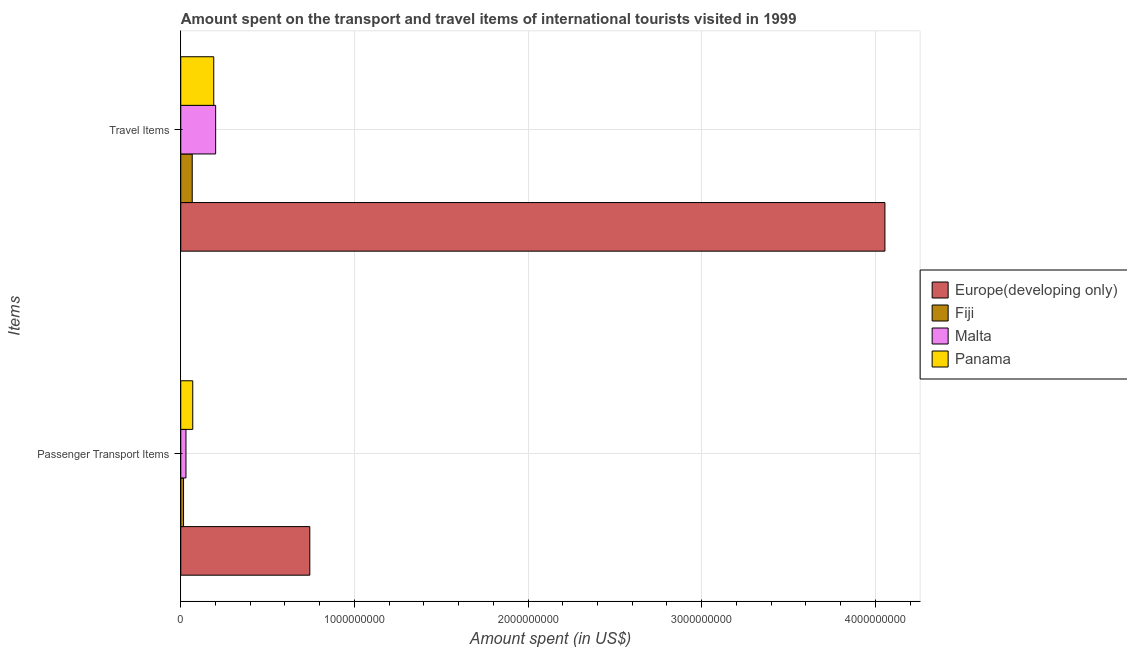How many groups of bars are there?
Your response must be concise. 2. Are the number of bars on each tick of the Y-axis equal?
Give a very brief answer. Yes. How many bars are there on the 2nd tick from the top?
Your response must be concise. 4. How many bars are there on the 2nd tick from the bottom?
Offer a very short reply. 4. What is the label of the 2nd group of bars from the top?
Ensure brevity in your answer.  Passenger Transport Items. What is the amount spent in travel items in Panama?
Your answer should be compact. 1.90e+08. Across all countries, what is the maximum amount spent on passenger transport items?
Offer a terse response. 7.43e+08. Across all countries, what is the minimum amount spent on passenger transport items?
Make the answer very short. 1.60e+07. In which country was the amount spent in travel items maximum?
Offer a very short reply. Europe(developing only). In which country was the amount spent in travel items minimum?
Give a very brief answer. Fiji. What is the total amount spent on passenger transport items in the graph?
Give a very brief answer. 8.58e+08. What is the difference between the amount spent in travel items in Fiji and that in Malta?
Keep it short and to the point. -1.35e+08. What is the difference between the amount spent in travel items in Malta and the amount spent on passenger transport items in Europe(developing only)?
Offer a terse response. -5.42e+08. What is the average amount spent on passenger transport items per country?
Give a very brief answer. 2.15e+08. What is the ratio of the amount spent in travel items in Malta to that in Fiji?
Give a very brief answer. 3.05. Is the amount spent in travel items in Europe(developing only) less than that in Fiji?
Give a very brief answer. No. In how many countries, is the amount spent on passenger transport items greater than the average amount spent on passenger transport items taken over all countries?
Make the answer very short. 1. What does the 4th bar from the top in Passenger Transport Items represents?
Provide a short and direct response. Europe(developing only). What does the 2nd bar from the bottom in Travel Items represents?
Your answer should be compact. Fiji. How many bars are there?
Ensure brevity in your answer.  8. How many countries are there in the graph?
Provide a short and direct response. 4. Are the values on the major ticks of X-axis written in scientific E-notation?
Your answer should be compact. No. Does the graph contain grids?
Your answer should be compact. Yes. Where does the legend appear in the graph?
Keep it short and to the point. Center right. What is the title of the graph?
Offer a very short reply. Amount spent on the transport and travel items of international tourists visited in 1999. Does "Yemen, Rep." appear as one of the legend labels in the graph?
Make the answer very short. No. What is the label or title of the X-axis?
Your answer should be compact. Amount spent (in US$). What is the label or title of the Y-axis?
Make the answer very short. Items. What is the Amount spent (in US$) in Europe(developing only) in Passenger Transport Items?
Keep it short and to the point. 7.43e+08. What is the Amount spent (in US$) in Fiji in Passenger Transport Items?
Your response must be concise. 1.60e+07. What is the Amount spent (in US$) in Malta in Passenger Transport Items?
Your answer should be compact. 3.00e+07. What is the Amount spent (in US$) of Panama in Passenger Transport Items?
Your response must be concise. 6.90e+07. What is the Amount spent (in US$) in Europe(developing only) in Travel Items?
Give a very brief answer. 4.06e+09. What is the Amount spent (in US$) in Fiji in Travel Items?
Offer a very short reply. 6.60e+07. What is the Amount spent (in US$) of Malta in Travel Items?
Ensure brevity in your answer.  2.01e+08. What is the Amount spent (in US$) in Panama in Travel Items?
Ensure brevity in your answer.  1.90e+08. Across all Items, what is the maximum Amount spent (in US$) of Europe(developing only)?
Give a very brief answer. 4.06e+09. Across all Items, what is the maximum Amount spent (in US$) in Fiji?
Make the answer very short. 6.60e+07. Across all Items, what is the maximum Amount spent (in US$) of Malta?
Provide a short and direct response. 2.01e+08. Across all Items, what is the maximum Amount spent (in US$) of Panama?
Your answer should be compact. 1.90e+08. Across all Items, what is the minimum Amount spent (in US$) in Europe(developing only)?
Give a very brief answer. 7.43e+08. Across all Items, what is the minimum Amount spent (in US$) in Fiji?
Offer a terse response. 1.60e+07. Across all Items, what is the minimum Amount spent (in US$) in Malta?
Your answer should be compact. 3.00e+07. Across all Items, what is the minimum Amount spent (in US$) in Panama?
Provide a succinct answer. 6.90e+07. What is the total Amount spent (in US$) of Europe(developing only) in the graph?
Your response must be concise. 4.80e+09. What is the total Amount spent (in US$) in Fiji in the graph?
Keep it short and to the point. 8.20e+07. What is the total Amount spent (in US$) of Malta in the graph?
Keep it short and to the point. 2.31e+08. What is the total Amount spent (in US$) in Panama in the graph?
Offer a very short reply. 2.59e+08. What is the difference between the Amount spent (in US$) in Europe(developing only) in Passenger Transport Items and that in Travel Items?
Your response must be concise. -3.31e+09. What is the difference between the Amount spent (in US$) in Fiji in Passenger Transport Items and that in Travel Items?
Your response must be concise. -5.00e+07. What is the difference between the Amount spent (in US$) of Malta in Passenger Transport Items and that in Travel Items?
Give a very brief answer. -1.71e+08. What is the difference between the Amount spent (in US$) in Panama in Passenger Transport Items and that in Travel Items?
Keep it short and to the point. -1.21e+08. What is the difference between the Amount spent (in US$) in Europe(developing only) in Passenger Transport Items and the Amount spent (in US$) in Fiji in Travel Items?
Your answer should be very brief. 6.77e+08. What is the difference between the Amount spent (in US$) in Europe(developing only) in Passenger Transport Items and the Amount spent (in US$) in Malta in Travel Items?
Offer a terse response. 5.42e+08. What is the difference between the Amount spent (in US$) of Europe(developing only) in Passenger Transport Items and the Amount spent (in US$) of Panama in Travel Items?
Give a very brief answer. 5.53e+08. What is the difference between the Amount spent (in US$) in Fiji in Passenger Transport Items and the Amount spent (in US$) in Malta in Travel Items?
Make the answer very short. -1.85e+08. What is the difference between the Amount spent (in US$) in Fiji in Passenger Transport Items and the Amount spent (in US$) in Panama in Travel Items?
Offer a terse response. -1.74e+08. What is the difference between the Amount spent (in US$) in Malta in Passenger Transport Items and the Amount spent (in US$) in Panama in Travel Items?
Offer a very short reply. -1.60e+08. What is the average Amount spent (in US$) of Europe(developing only) per Items?
Ensure brevity in your answer.  2.40e+09. What is the average Amount spent (in US$) in Fiji per Items?
Provide a short and direct response. 4.10e+07. What is the average Amount spent (in US$) in Malta per Items?
Your response must be concise. 1.16e+08. What is the average Amount spent (in US$) of Panama per Items?
Your answer should be very brief. 1.30e+08. What is the difference between the Amount spent (in US$) of Europe(developing only) and Amount spent (in US$) of Fiji in Passenger Transport Items?
Provide a short and direct response. 7.27e+08. What is the difference between the Amount spent (in US$) of Europe(developing only) and Amount spent (in US$) of Malta in Passenger Transport Items?
Provide a succinct answer. 7.13e+08. What is the difference between the Amount spent (in US$) in Europe(developing only) and Amount spent (in US$) in Panama in Passenger Transport Items?
Your answer should be compact. 6.74e+08. What is the difference between the Amount spent (in US$) of Fiji and Amount spent (in US$) of Malta in Passenger Transport Items?
Provide a short and direct response. -1.40e+07. What is the difference between the Amount spent (in US$) in Fiji and Amount spent (in US$) in Panama in Passenger Transport Items?
Your response must be concise. -5.30e+07. What is the difference between the Amount spent (in US$) of Malta and Amount spent (in US$) of Panama in Passenger Transport Items?
Your answer should be very brief. -3.90e+07. What is the difference between the Amount spent (in US$) of Europe(developing only) and Amount spent (in US$) of Fiji in Travel Items?
Offer a terse response. 3.99e+09. What is the difference between the Amount spent (in US$) of Europe(developing only) and Amount spent (in US$) of Malta in Travel Items?
Your answer should be very brief. 3.85e+09. What is the difference between the Amount spent (in US$) in Europe(developing only) and Amount spent (in US$) in Panama in Travel Items?
Your answer should be very brief. 3.87e+09. What is the difference between the Amount spent (in US$) of Fiji and Amount spent (in US$) of Malta in Travel Items?
Your answer should be compact. -1.35e+08. What is the difference between the Amount spent (in US$) of Fiji and Amount spent (in US$) of Panama in Travel Items?
Keep it short and to the point. -1.24e+08. What is the difference between the Amount spent (in US$) in Malta and Amount spent (in US$) in Panama in Travel Items?
Your answer should be very brief. 1.10e+07. What is the ratio of the Amount spent (in US$) of Europe(developing only) in Passenger Transport Items to that in Travel Items?
Your answer should be very brief. 0.18. What is the ratio of the Amount spent (in US$) of Fiji in Passenger Transport Items to that in Travel Items?
Provide a succinct answer. 0.24. What is the ratio of the Amount spent (in US$) in Malta in Passenger Transport Items to that in Travel Items?
Your answer should be very brief. 0.15. What is the ratio of the Amount spent (in US$) in Panama in Passenger Transport Items to that in Travel Items?
Make the answer very short. 0.36. What is the difference between the highest and the second highest Amount spent (in US$) of Europe(developing only)?
Your answer should be very brief. 3.31e+09. What is the difference between the highest and the second highest Amount spent (in US$) of Malta?
Keep it short and to the point. 1.71e+08. What is the difference between the highest and the second highest Amount spent (in US$) in Panama?
Your answer should be compact. 1.21e+08. What is the difference between the highest and the lowest Amount spent (in US$) of Europe(developing only)?
Offer a very short reply. 3.31e+09. What is the difference between the highest and the lowest Amount spent (in US$) in Malta?
Provide a short and direct response. 1.71e+08. What is the difference between the highest and the lowest Amount spent (in US$) of Panama?
Make the answer very short. 1.21e+08. 